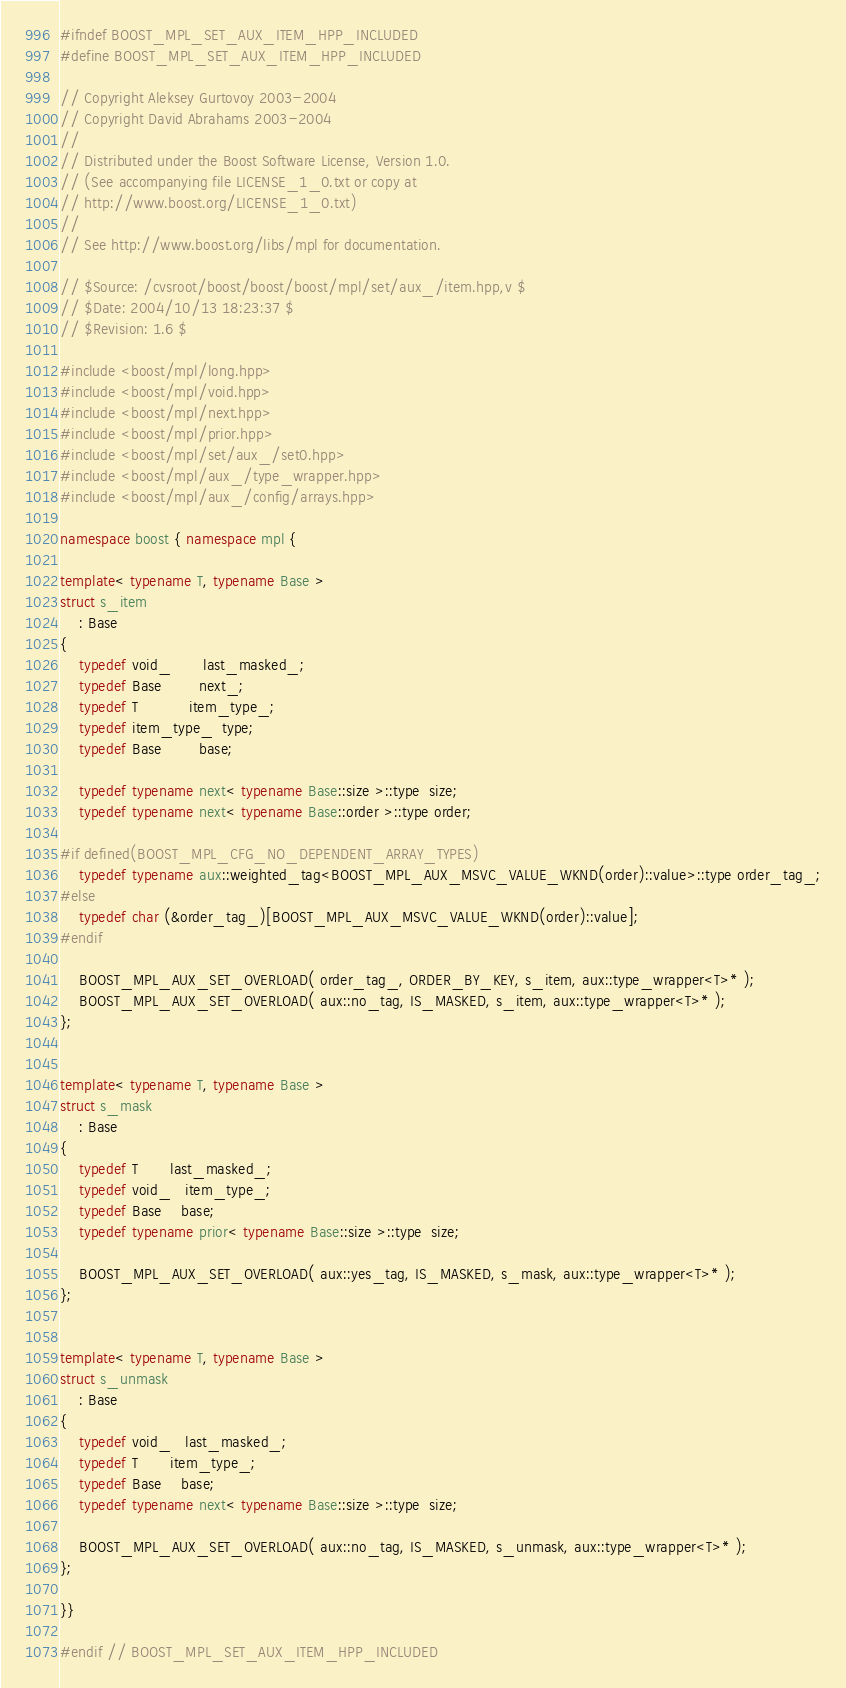Convert code to text. <code><loc_0><loc_0><loc_500><loc_500><_C++_>
#ifndef BOOST_MPL_SET_AUX_ITEM_HPP_INCLUDED
#define BOOST_MPL_SET_AUX_ITEM_HPP_INCLUDED

// Copyright Aleksey Gurtovoy 2003-2004
// Copyright David Abrahams 2003-2004
//
// Distributed under the Boost Software License, Version 1.0. 
// (See accompanying file LICENSE_1_0.txt or copy at 
// http://www.boost.org/LICENSE_1_0.txt)
//
// See http://www.boost.org/libs/mpl for documentation.

// $Source: /cvsroot/boost/boost/boost/mpl/set/aux_/item.hpp,v $
// $Date: 2004/10/13 18:23:37 $
// $Revision: 1.6 $

#include <boost/mpl/long.hpp>
#include <boost/mpl/void.hpp>
#include <boost/mpl/next.hpp>
#include <boost/mpl/prior.hpp>
#include <boost/mpl/set/aux_/set0.hpp>
#include <boost/mpl/aux_/type_wrapper.hpp>
#include <boost/mpl/aux_/config/arrays.hpp>

namespace boost { namespace mpl {

template< typename T, typename Base >
struct s_item
    : Base
{
    typedef void_       last_masked_;
    typedef Base        next_;
    typedef T           item_type_;
    typedef item_type_  type;
    typedef Base        base;
    
    typedef typename next< typename Base::size >::type  size;
    typedef typename next< typename Base::order >::type order;

#if defined(BOOST_MPL_CFG_NO_DEPENDENT_ARRAY_TYPES)
    typedef typename aux::weighted_tag<BOOST_MPL_AUX_MSVC_VALUE_WKND(order)::value>::type order_tag_;
#else
    typedef char (&order_tag_)[BOOST_MPL_AUX_MSVC_VALUE_WKND(order)::value];
#endif

    BOOST_MPL_AUX_SET_OVERLOAD( order_tag_, ORDER_BY_KEY, s_item, aux::type_wrapper<T>* );
    BOOST_MPL_AUX_SET_OVERLOAD( aux::no_tag, IS_MASKED, s_item, aux::type_wrapper<T>* );
};


template< typename T, typename Base >
struct s_mask
    : Base
{
    typedef T       last_masked_;
    typedef void_   item_type_;
    typedef Base    base;
    typedef typename prior< typename Base::size >::type  size;

    BOOST_MPL_AUX_SET_OVERLOAD( aux::yes_tag, IS_MASKED, s_mask, aux::type_wrapper<T>* );
};


template< typename T, typename Base >
struct s_unmask
    : Base
{
    typedef void_   last_masked_;
    typedef T       item_type_;
    typedef Base    base;
    typedef typename next< typename Base::size >::type  size;

    BOOST_MPL_AUX_SET_OVERLOAD( aux::no_tag, IS_MASKED, s_unmask, aux::type_wrapper<T>* );
};

}}

#endif // BOOST_MPL_SET_AUX_ITEM_HPP_INCLUDED
</code> 